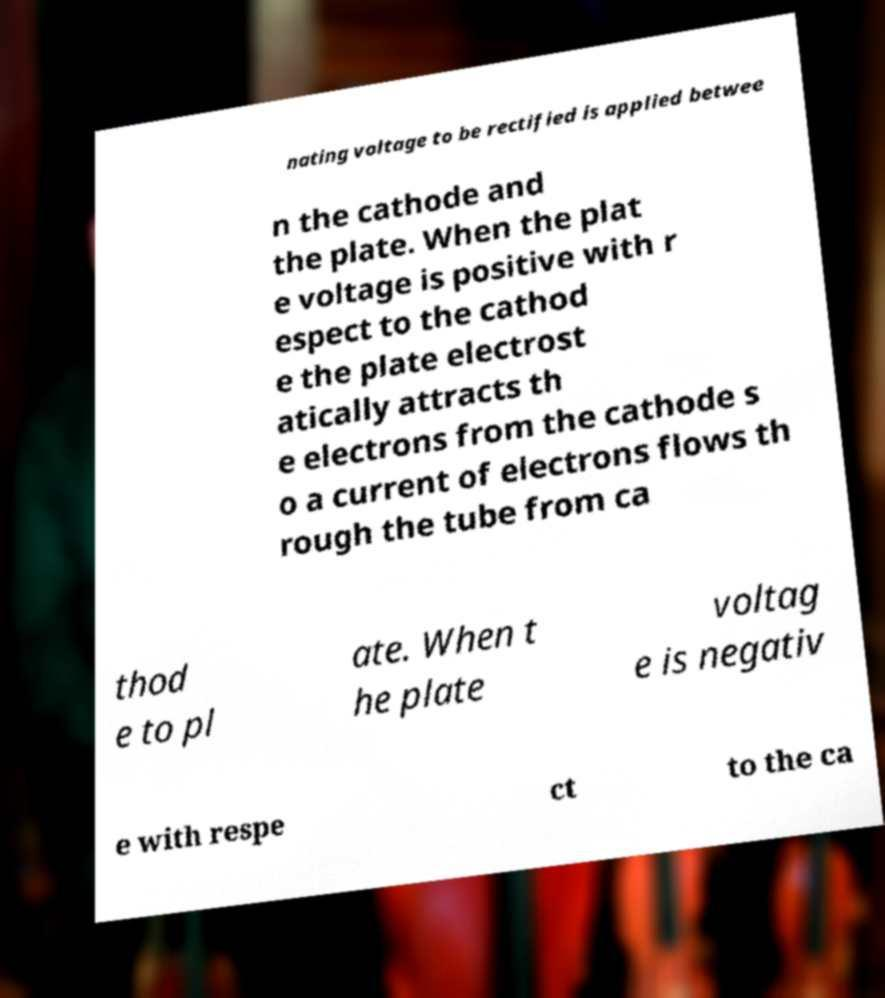Please identify and transcribe the text found in this image. nating voltage to be rectified is applied betwee n the cathode and the plate. When the plat e voltage is positive with r espect to the cathod e the plate electrost atically attracts th e electrons from the cathode s o a current of electrons flows th rough the tube from ca thod e to pl ate. When t he plate voltag e is negativ e with respe ct to the ca 